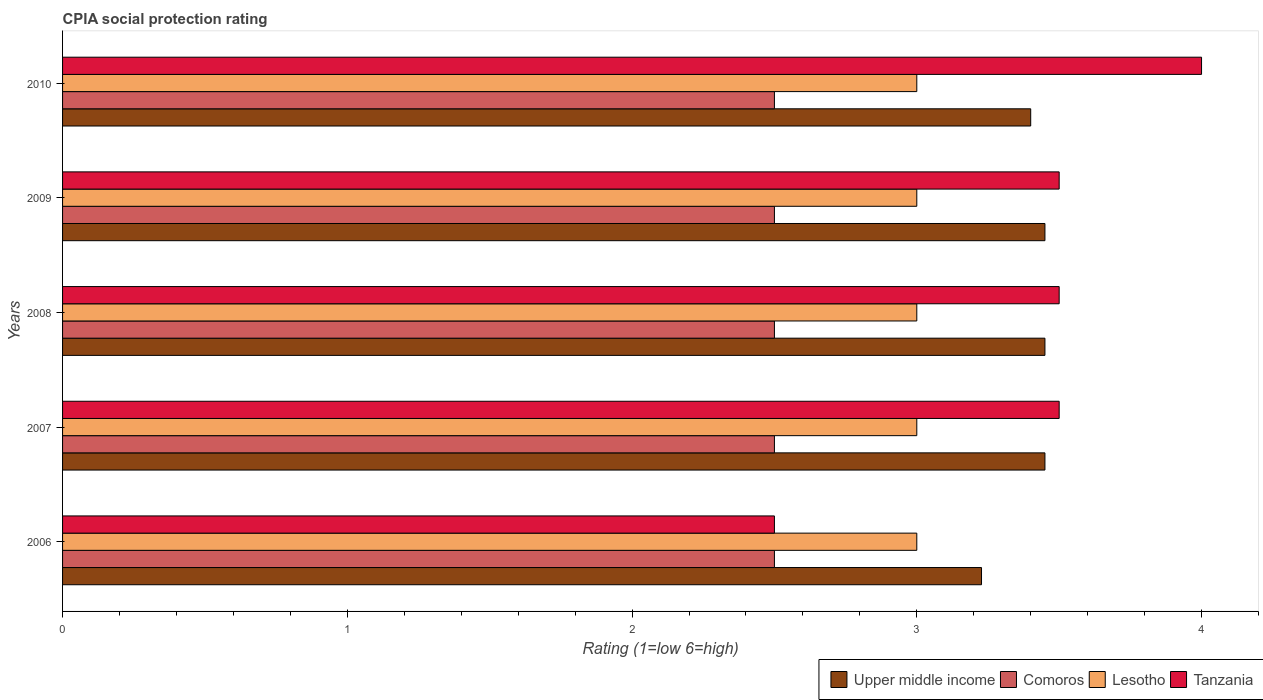How many different coloured bars are there?
Your answer should be very brief. 4. How many groups of bars are there?
Provide a short and direct response. 5. Are the number of bars per tick equal to the number of legend labels?
Give a very brief answer. Yes. Are the number of bars on each tick of the Y-axis equal?
Ensure brevity in your answer.  Yes. How many bars are there on the 5th tick from the bottom?
Make the answer very short. 4. In how many cases, is the number of bars for a given year not equal to the number of legend labels?
Your answer should be compact. 0. What is the CPIA rating in Upper middle income in 2009?
Provide a short and direct response. 3.45. Across all years, what is the minimum CPIA rating in Comoros?
Offer a terse response. 2.5. What is the total CPIA rating in Upper middle income in the graph?
Your response must be concise. 16.98. What is the difference between the CPIA rating in Comoros in 2009 and the CPIA rating in Tanzania in 2007?
Your answer should be compact. -1. In how many years, is the CPIA rating in Tanzania greater than 0.2 ?
Ensure brevity in your answer.  5. What is the ratio of the CPIA rating in Upper middle income in 2008 to that in 2010?
Your answer should be compact. 1.01. Is the sum of the CPIA rating in Comoros in 2006 and 2009 greater than the maximum CPIA rating in Upper middle income across all years?
Keep it short and to the point. Yes. Is it the case that in every year, the sum of the CPIA rating in Lesotho and CPIA rating in Tanzania is greater than the sum of CPIA rating in Upper middle income and CPIA rating in Comoros?
Provide a short and direct response. Yes. What does the 1st bar from the top in 2010 represents?
Provide a short and direct response. Tanzania. What does the 3rd bar from the bottom in 2008 represents?
Your response must be concise. Lesotho. How many bars are there?
Offer a very short reply. 20. Are all the bars in the graph horizontal?
Your answer should be very brief. Yes. Does the graph contain any zero values?
Your answer should be compact. No. Where does the legend appear in the graph?
Give a very brief answer. Bottom right. How are the legend labels stacked?
Provide a short and direct response. Horizontal. What is the title of the graph?
Your answer should be very brief. CPIA social protection rating. Does "Myanmar" appear as one of the legend labels in the graph?
Your answer should be very brief. No. What is the label or title of the Y-axis?
Your answer should be very brief. Years. What is the Rating (1=low 6=high) in Upper middle income in 2006?
Keep it short and to the point. 3.23. What is the Rating (1=low 6=high) in Upper middle income in 2007?
Offer a terse response. 3.45. What is the Rating (1=low 6=high) in Comoros in 2007?
Your answer should be very brief. 2.5. What is the Rating (1=low 6=high) in Lesotho in 2007?
Keep it short and to the point. 3. What is the Rating (1=low 6=high) of Upper middle income in 2008?
Provide a succinct answer. 3.45. What is the Rating (1=low 6=high) in Comoros in 2008?
Make the answer very short. 2.5. What is the Rating (1=low 6=high) of Lesotho in 2008?
Ensure brevity in your answer.  3. What is the Rating (1=low 6=high) in Tanzania in 2008?
Keep it short and to the point. 3.5. What is the Rating (1=low 6=high) in Upper middle income in 2009?
Your response must be concise. 3.45. What is the Rating (1=low 6=high) of Lesotho in 2009?
Your answer should be compact. 3. What is the Rating (1=low 6=high) in Comoros in 2010?
Ensure brevity in your answer.  2.5. Across all years, what is the maximum Rating (1=low 6=high) of Upper middle income?
Make the answer very short. 3.45. Across all years, what is the maximum Rating (1=low 6=high) in Comoros?
Provide a short and direct response. 2.5. Across all years, what is the maximum Rating (1=low 6=high) of Tanzania?
Your response must be concise. 4. Across all years, what is the minimum Rating (1=low 6=high) of Upper middle income?
Offer a terse response. 3.23. Across all years, what is the minimum Rating (1=low 6=high) of Comoros?
Your response must be concise. 2.5. Across all years, what is the minimum Rating (1=low 6=high) of Lesotho?
Your response must be concise. 3. Across all years, what is the minimum Rating (1=low 6=high) in Tanzania?
Provide a short and direct response. 2.5. What is the total Rating (1=low 6=high) of Upper middle income in the graph?
Offer a very short reply. 16.98. What is the difference between the Rating (1=low 6=high) in Upper middle income in 2006 and that in 2007?
Offer a very short reply. -0.22. What is the difference between the Rating (1=low 6=high) in Comoros in 2006 and that in 2007?
Provide a succinct answer. 0. What is the difference between the Rating (1=low 6=high) in Tanzania in 2006 and that in 2007?
Give a very brief answer. -1. What is the difference between the Rating (1=low 6=high) in Upper middle income in 2006 and that in 2008?
Offer a very short reply. -0.22. What is the difference between the Rating (1=low 6=high) of Tanzania in 2006 and that in 2008?
Give a very brief answer. -1. What is the difference between the Rating (1=low 6=high) in Upper middle income in 2006 and that in 2009?
Your answer should be compact. -0.22. What is the difference between the Rating (1=low 6=high) in Comoros in 2006 and that in 2009?
Your response must be concise. 0. What is the difference between the Rating (1=low 6=high) of Lesotho in 2006 and that in 2009?
Give a very brief answer. 0. What is the difference between the Rating (1=low 6=high) of Tanzania in 2006 and that in 2009?
Ensure brevity in your answer.  -1. What is the difference between the Rating (1=low 6=high) in Upper middle income in 2006 and that in 2010?
Provide a short and direct response. -0.17. What is the difference between the Rating (1=low 6=high) in Lesotho in 2006 and that in 2010?
Make the answer very short. 0. What is the difference between the Rating (1=low 6=high) in Upper middle income in 2007 and that in 2008?
Provide a succinct answer. 0. What is the difference between the Rating (1=low 6=high) of Comoros in 2007 and that in 2008?
Your response must be concise. 0. What is the difference between the Rating (1=low 6=high) of Lesotho in 2007 and that in 2008?
Your answer should be very brief. 0. What is the difference between the Rating (1=low 6=high) in Tanzania in 2007 and that in 2008?
Ensure brevity in your answer.  0. What is the difference between the Rating (1=low 6=high) in Upper middle income in 2007 and that in 2009?
Your answer should be compact. 0. What is the difference between the Rating (1=low 6=high) of Upper middle income in 2007 and that in 2010?
Provide a short and direct response. 0.05. What is the difference between the Rating (1=low 6=high) in Tanzania in 2007 and that in 2010?
Provide a succinct answer. -0.5. What is the difference between the Rating (1=low 6=high) in Upper middle income in 2008 and that in 2009?
Provide a short and direct response. 0. What is the difference between the Rating (1=low 6=high) in Comoros in 2008 and that in 2009?
Offer a very short reply. 0. What is the difference between the Rating (1=low 6=high) of Lesotho in 2008 and that in 2009?
Your response must be concise. 0. What is the difference between the Rating (1=low 6=high) of Tanzania in 2008 and that in 2009?
Your answer should be very brief. 0. What is the difference between the Rating (1=low 6=high) of Upper middle income in 2009 and that in 2010?
Provide a short and direct response. 0.05. What is the difference between the Rating (1=low 6=high) of Comoros in 2009 and that in 2010?
Offer a terse response. 0. What is the difference between the Rating (1=low 6=high) in Tanzania in 2009 and that in 2010?
Provide a succinct answer. -0.5. What is the difference between the Rating (1=low 6=high) in Upper middle income in 2006 and the Rating (1=low 6=high) in Comoros in 2007?
Offer a terse response. 0.73. What is the difference between the Rating (1=low 6=high) in Upper middle income in 2006 and the Rating (1=low 6=high) in Lesotho in 2007?
Provide a succinct answer. 0.23. What is the difference between the Rating (1=low 6=high) of Upper middle income in 2006 and the Rating (1=low 6=high) of Tanzania in 2007?
Keep it short and to the point. -0.27. What is the difference between the Rating (1=low 6=high) in Comoros in 2006 and the Rating (1=low 6=high) in Tanzania in 2007?
Ensure brevity in your answer.  -1. What is the difference between the Rating (1=low 6=high) of Lesotho in 2006 and the Rating (1=low 6=high) of Tanzania in 2007?
Make the answer very short. -0.5. What is the difference between the Rating (1=low 6=high) of Upper middle income in 2006 and the Rating (1=low 6=high) of Comoros in 2008?
Make the answer very short. 0.73. What is the difference between the Rating (1=low 6=high) in Upper middle income in 2006 and the Rating (1=low 6=high) in Lesotho in 2008?
Your response must be concise. 0.23. What is the difference between the Rating (1=low 6=high) of Upper middle income in 2006 and the Rating (1=low 6=high) of Tanzania in 2008?
Offer a terse response. -0.27. What is the difference between the Rating (1=low 6=high) of Upper middle income in 2006 and the Rating (1=low 6=high) of Comoros in 2009?
Provide a succinct answer. 0.73. What is the difference between the Rating (1=low 6=high) of Upper middle income in 2006 and the Rating (1=low 6=high) of Lesotho in 2009?
Give a very brief answer. 0.23. What is the difference between the Rating (1=low 6=high) of Upper middle income in 2006 and the Rating (1=low 6=high) of Tanzania in 2009?
Your response must be concise. -0.27. What is the difference between the Rating (1=low 6=high) in Comoros in 2006 and the Rating (1=low 6=high) in Tanzania in 2009?
Provide a succinct answer. -1. What is the difference between the Rating (1=low 6=high) in Upper middle income in 2006 and the Rating (1=low 6=high) in Comoros in 2010?
Offer a very short reply. 0.73. What is the difference between the Rating (1=low 6=high) in Upper middle income in 2006 and the Rating (1=low 6=high) in Lesotho in 2010?
Provide a succinct answer. 0.23. What is the difference between the Rating (1=low 6=high) in Upper middle income in 2006 and the Rating (1=low 6=high) in Tanzania in 2010?
Your answer should be very brief. -0.77. What is the difference between the Rating (1=low 6=high) in Upper middle income in 2007 and the Rating (1=low 6=high) in Lesotho in 2008?
Keep it short and to the point. 0.45. What is the difference between the Rating (1=low 6=high) in Upper middle income in 2007 and the Rating (1=low 6=high) in Tanzania in 2008?
Give a very brief answer. -0.05. What is the difference between the Rating (1=low 6=high) in Comoros in 2007 and the Rating (1=low 6=high) in Lesotho in 2008?
Provide a succinct answer. -0.5. What is the difference between the Rating (1=low 6=high) of Comoros in 2007 and the Rating (1=low 6=high) of Tanzania in 2008?
Your response must be concise. -1. What is the difference between the Rating (1=low 6=high) in Upper middle income in 2007 and the Rating (1=low 6=high) in Lesotho in 2009?
Ensure brevity in your answer.  0.45. What is the difference between the Rating (1=low 6=high) of Upper middle income in 2007 and the Rating (1=low 6=high) of Tanzania in 2009?
Give a very brief answer. -0.05. What is the difference between the Rating (1=low 6=high) of Comoros in 2007 and the Rating (1=low 6=high) of Lesotho in 2009?
Your answer should be compact. -0.5. What is the difference between the Rating (1=low 6=high) of Comoros in 2007 and the Rating (1=low 6=high) of Tanzania in 2009?
Provide a short and direct response. -1. What is the difference between the Rating (1=low 6=high) of Lesotho in 2007 and the Rating (1=low 6=high) of Tanzania in 2009?
Offer a terse response. -0.5. What is the difference between the Rating (1=low 6=high) of Upper middle income in 2007 and the Rating (1=low 6=high) of Lesotho in 2010?
Keep it short and to the point. 0.45. What is the difference between the Rating (1=low 6=high) of Upper middle income in 2007 and the Rating (1=low 6=high) of Tanzania in 2010?
Offer a very short reply. -0.55. What is the difference between the Rating (1=low 6=high) in Comoros in 2007 and the Rating (1=low 6=high) in Tanzania in 2010?
Provide a short and direct response. -1.5. What is the difference between the Rating (1=low 6=high) of Upper middle income in 2008 and the Rating (1=low 6=high) of Comoros in 2009?
Your answer should be very brief. 0.95. What is the difference between the Rating (1=low 6=high) in Upper middle income in 2008 and the Rating (1=low 6=high) in Lesotho in 2009?
Provide a succinct answer. 0.45. What is the difference between the Rating (1=low 6=high) of Upper middle income in 2008 and the Rating (1=low 6=high) of Lesotho in 2010?
Ensure brevity in your answer.  0.45. What is the difference between the Rating (1=low 6=high) in Upper middle income in 2008 and the Rating (1=low 6=high) in Tanzania in 2010?
Offer a terse response. -0.55. What is the difference between the Rating (1=low 6=high) of Comoros in 2008 and the Rating (1=low 6=high) of Tanzania in 2010?
Your answer should be compact. -1.5. What is the difference between the Rating (1=low 6=high) of Lesotho in 2008 and the Rating (1=low 6=high) of Tanzania in 2010?
Your answer should be compact. -1. What is the difference between the Rating (1=low 6=high) in Upper middle income in 2009 and the Rating (1=low 6=high) in Comoros in 2010?
Your answer should be very brief. 0.95. What is the difference between the Rating (1=low 6=high) in Upper middle income in 2009 and the Rating (1=low 6=high) in Lesotho in 2010?
Offer a terse response. 0.45. What is the difference between the Rating (1=low 6=high) of Upper middle income in 2009 and the Rating (1=low 6=high) of Tanzania in 2010?
Your response must be concise. -0.55. What is the difference between the Rating (1=low 6=high) of Comoros in 2009 and the Rating (1=low 6=high) of Lesotho in 2010?
Provide a short and direct response. -0.5. What is the average Rating (1=low 6=high) of Upper middle income per year?
Keep it short and to the point. 3.4. What is the average Rating (1=low 6=high) of Lesotho per year?
Your answer should be very brief. 3. What is the average Rating (1=low 6=high) in Tanzania per year?
Your answer should be very brief. 3.4. In the year 2006, what is the difference between the Rating (1=low 6=high) of Upper middle income and Rating (1=low 6=high) of Comoros?
Your response must be concise. 0.73. In the year 2006, what is the difference between the Rating (1=low 6=high) of Upper middle income and Rating (1=low 6=high) of Lesotho?
Offer a very short reply. 0.23. In the year 2006, what is the difference between the Rating (1=low 6=high) in Upper middle income and Rating (1=low 6=high) in Tanzania?
Your response must be concise. 0.73. In the year 2007, what is the difference between the Rating (1=low 6=high) in Upper middle income and Rating (1=low 6=high) in Comoros?
Your answer should be compact. 0.95. In the year 2007, what is the difference between the Rating (1=low 6=high) in Upper middle income and Rating (1=low 6=high) in Lesotho?
Provide a short and direct response. 0.45. In the year 2007, what is the difference between the Rating (1=low 6=high) in Upper middle income and Rating (1=low 6=high) in Tanzania?
Your response must be concise. -0.05. In the year 2007, what is the difference between the Rating (1=low 6=high) in Lesotho and Rating (1=low 6=high) in Tanzania?
Your response must be concise. -0.5. In the year 2008, what is the difference between the Rating (1=low 6=high) in Upper middle income and Rating (1=low 6=high) in Lesotho?
Give a very brief answer. 0.45. In the year 2008, what is the difference between the Rating (1=low 6=high) in Comoros and Rating (1=low 6=high) in Lesotho?
Provide a succinct answer. -0.5. In the year 2008, what is the difference between the Rating (1=low 6=high) in Comoros and Rating (1=low 6=high) in Tanzania?
Your response must be concise. -1. In the year 2008, what is the difference between the Rating (1=low 6=high) in Lesotho and Rating (1=low 6=high) in Tanzania?
Offer a very short reply. -0.5. In the year 2009, what is the difference between the Rating (1=low 6=high) in Upper middle income and Rating (1=low 6=high) in Lesotho?
Offer a terse response. 0.45. In the year 2009, what is the difference between the Rating (1=low 6=high) of Lesotho and Rating (1=low 6=high) of Tanzania?
Your answer should be very brief. -0.5. In the year 2010, what is the difference between the Rating (1=low 6=high) of Upper middle income and Rating (1=low 6=high) of Lesotho?
Offer a very short reply. 0.4. In the year 2010, what is the difference between the Rating (1=low 6=high) in Comoros and Rating (1=low 6=high) in Lesotho?
Provide a succinct answer. -0.5. In the year 2010, what is the difference between the Rating (1=low 6=high) of Comoros and Rating (1=low 6=high) of Tanzania?
Offer a very short reply. -1.5. What is the ratio of the Rating (1=low 6=high) of Upper middle income in 2006 to that in 2007?
Your response must be concise. 0.94. What is the ratio of the Rating (1=low 6=high) of Upper middle income in 2006 to that in 2008?
Make the answer very short. 0.94. What is the ratio of the Rating (1=low 6=high) of Comoros in 2006 to that in 2008?
Your answer should be compact. 1. What is the ratio of the Rating (1=low 6=high) in Upper middle income in 2006 to that in 2009?
Provide a short and direct response. 0.94. What is the ratio of the Rating (1=low 6=high) in Comoros in 2006 to that in 2009?
Make the answer very short. 1. What is the ratio of the Rating (1=low 6=high) of Lesotho in 2006 to that in 2009?
Your response must be concise. 1. What is the ratio of the Rating (1=low 6=high) in Tanzania in 2006 to that in 2009?
Provide a short and direct response. 0.71. What is the ratio of the Rating (1=low 6=high) of Upper middle income in 2006 to that in 2010?
Provide a short and direct response. 0.95. What is the ratio of the Rating (1=low 6=high) of Tanzania in 2006 to that in 2010?
Provide a short and direct response. 0.62. What is the ratio of the Rating (1=low 6=high) of Comoros in 2007 to that in 2008?
Provide a succinct answer. 1. What is the ratio of the Rating (1=low 6=high) of Lesotho in 2007 to that in 2008?
Your answer should be compact. 1. What is the ratio of the Rating (1=low 6=high) of Upper middle income in 2007 to that in 2009?
Your answer should be compact. 1. What is the ratio of the Rating (1=low 6=high) in Upper middle income in 2007 to that in 2010?
Your answer should be very brief. 1.01. What is the ratio of the Rating (1=low 6=high) of Lesotho in 2007 to that in 2010?
Your response must be concise. 1. What is the ratio of the Rating (1=low 6=high) in Lesotho in 2008 to that in 2009?
Offer a terse response. 1. What is the ratio of the Rating (1=low 6=high) of Tanzania in 2008 to that in 2009?
Give a very brief answer. 1. What is the ratio of the Rating (1=low 6=high) of Upper middle income in 2008 to that in 2010?
Provide a short and direct response. 1.01. What is the ratio of the Rating (1=low 6=high) in Lesotho in 2008 to that in 2010?
Provide a short and direct response. 1. What is the ratio of the Rating (1=low 6=high) of Upper middle income in 2009 to that in 2010?
Your answer should be very brief. 1.01. What is the ratio of the Rating (1=low 6=high) in Comoros in 2009 to that in 2010?
Offer a terse response. 1. What is the ratio of the Rating (1=low 6=high) in Tanzania in 2009 to that in 2010?
Give a very brief answer. 0.88. What is the difference between the highest and the second highest Rating (1=low 6=high) in Comoros?
Your response must be concise. 0. What is the difference between the highest and the second highest Rating (1=low 6=high) in Lesotho?
Offer a terse response. 0. What is the difference between the highest and the second highest Rating (1=low 6=high) in Tanzania?
Your answer should be compact. 0.5. What is the difference between the highest and the lowest Rating (1=low 6=high) of Upper middle income?
Offer a very short reply. 0.22. What is the difference between the highest and the lowest Rating (1=low 6=high) of Comoros?
Offer a very short reply. 0. What is the difference between the highest and the lowest Rating (1=low 6=high) in Tanzania?
Keep it short and to the point. 1.5. 